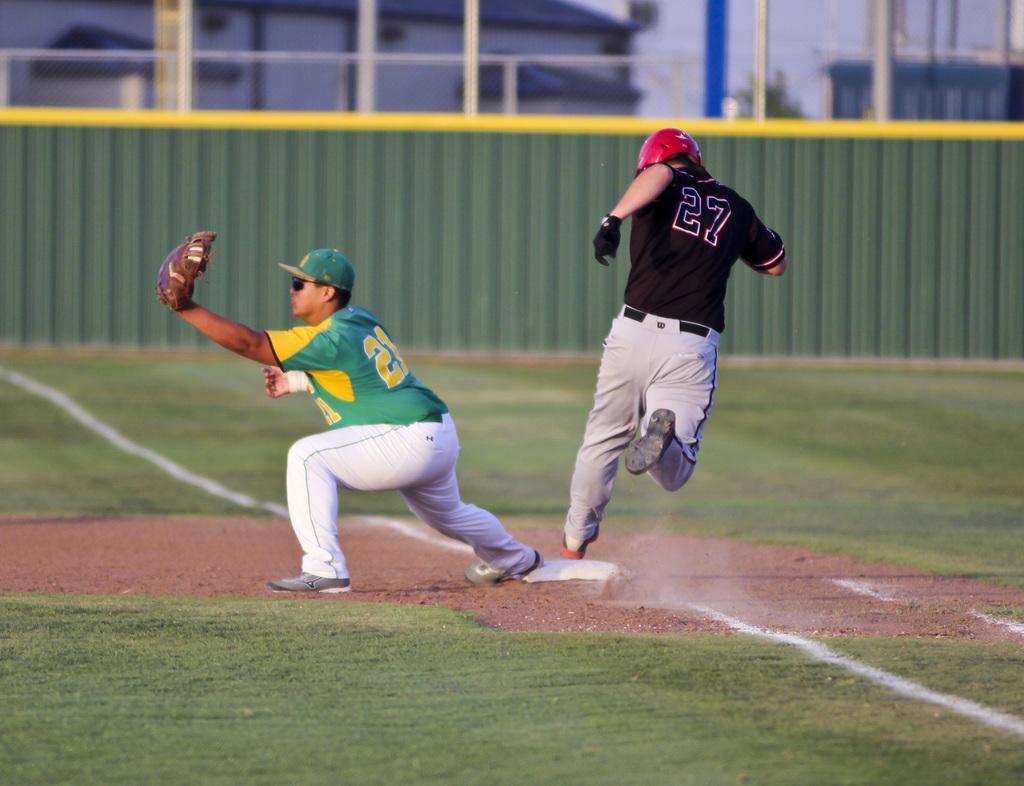Please provide a concise description of this image. In this image it seems like it is a baseball match in which there is a baseball player running on the ground while the other man is holding the ball with the glove. In the background there is a fence. Above the fence there are poles. On the ground there is grass and sand. 